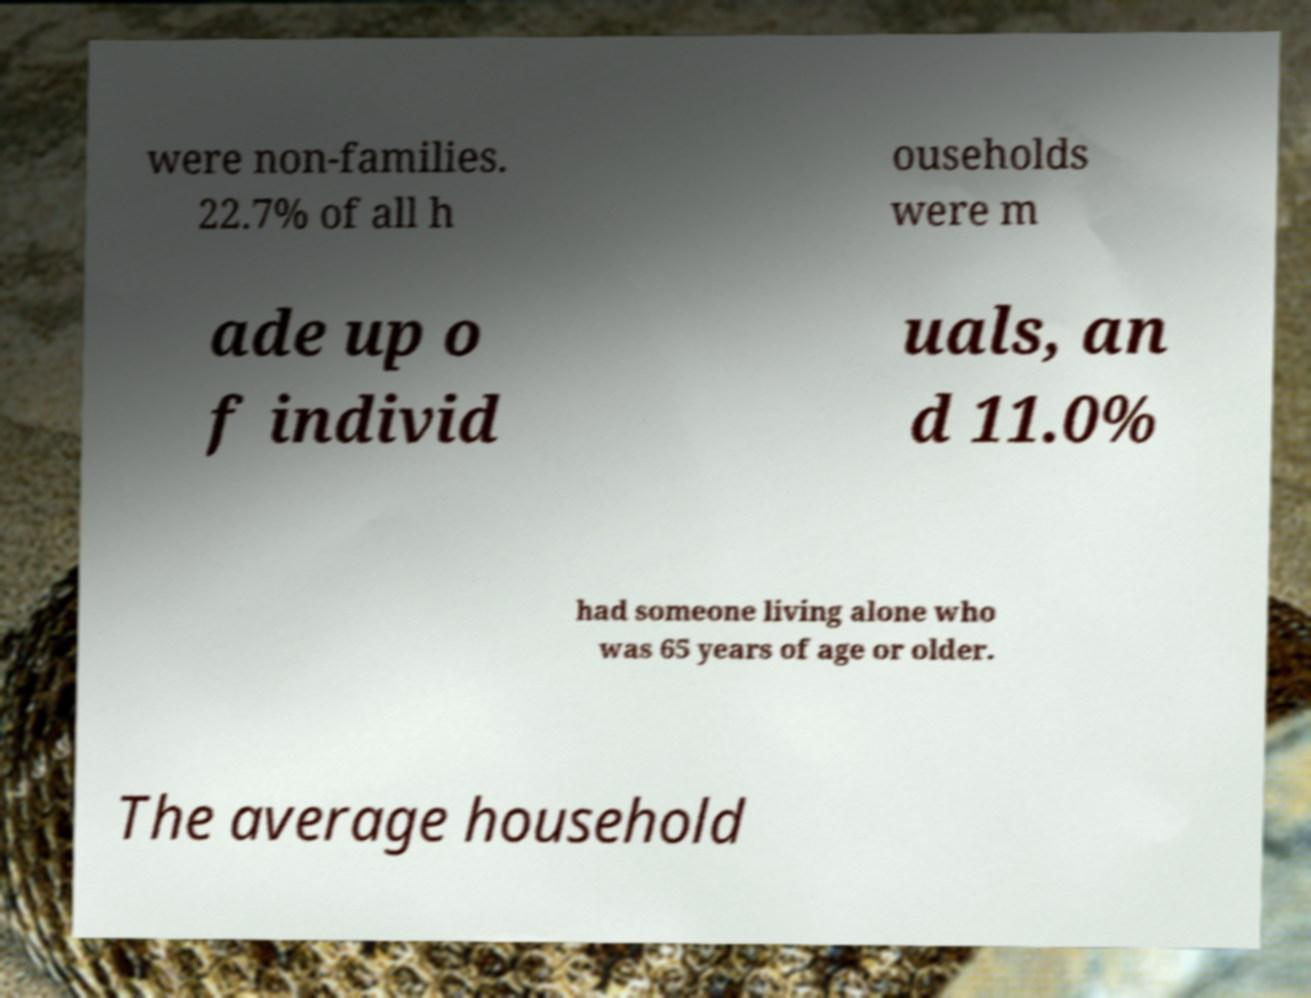I need the written content from this picture converted into text. Can you do that? were non-families. 22.7% of all h ouseholds were m ade up o f individ uals, an d 11.0% had someone living alone who was 65 years of age or older. The average household 